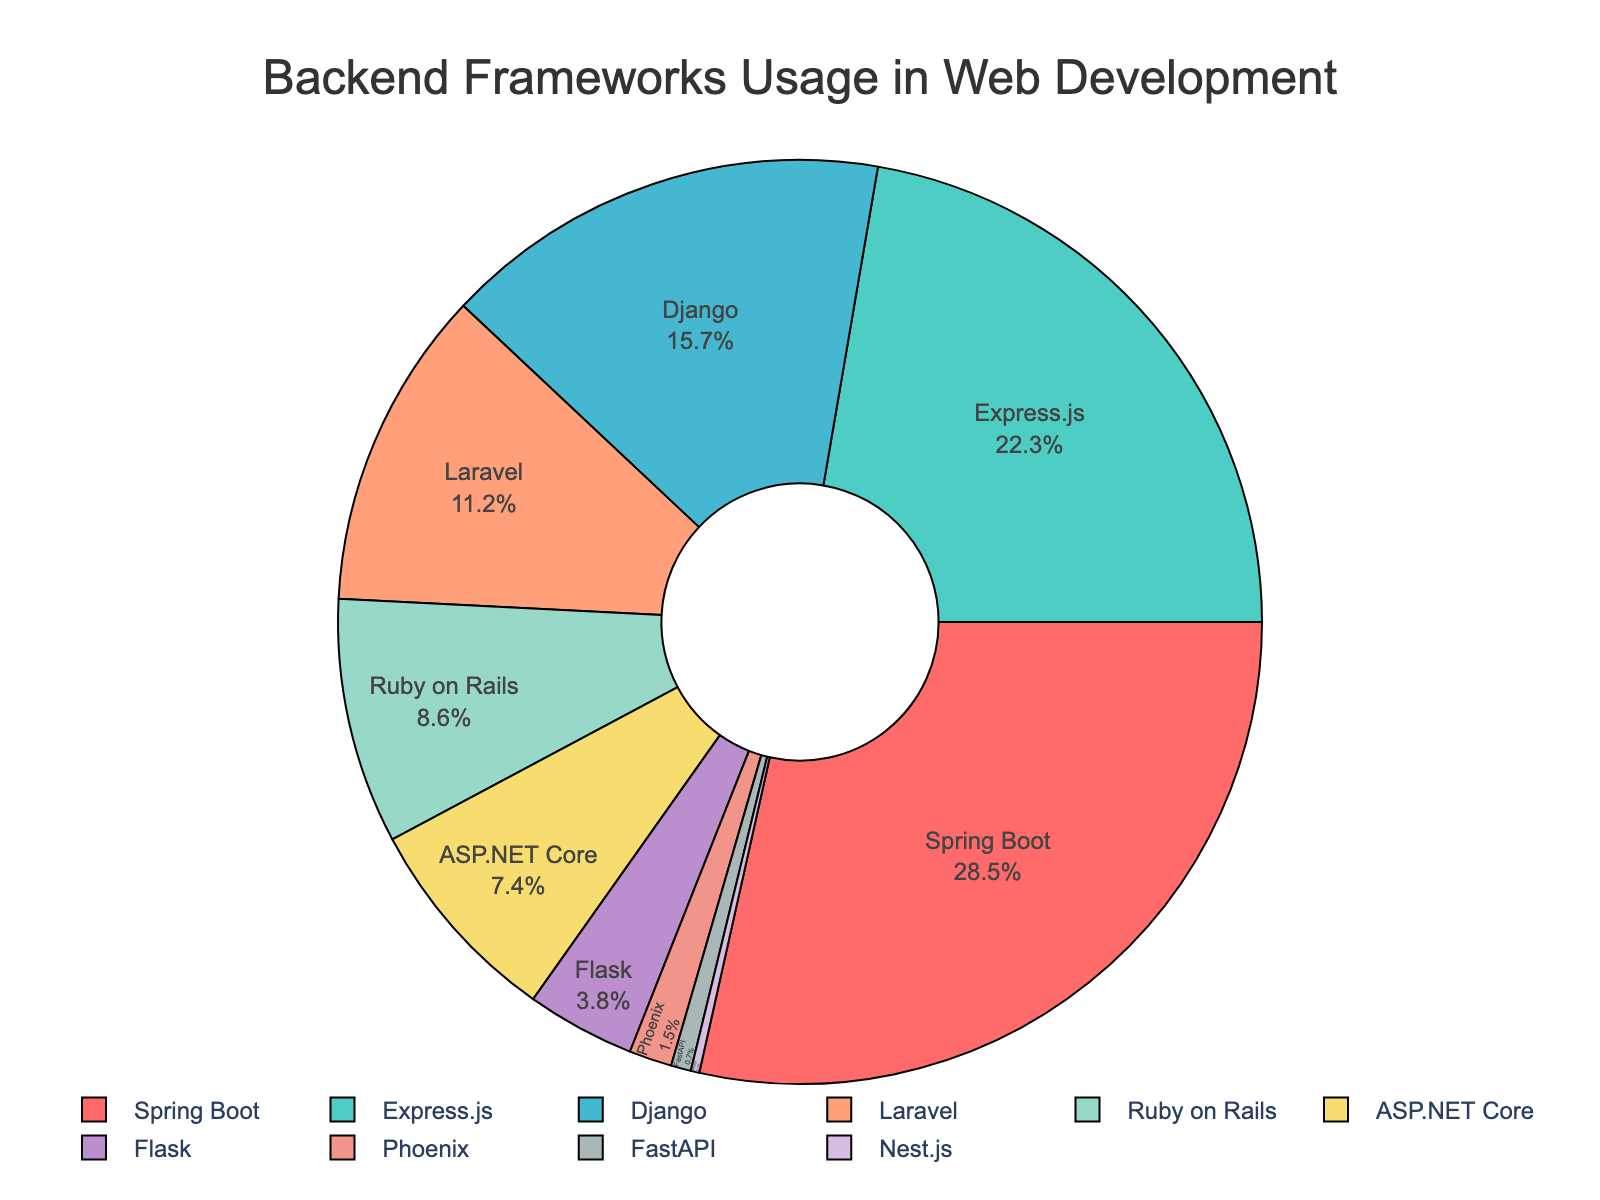What is the framework with the highest percentage usage? Looking at the figure, the segment corresponding to the highest usage percentage is for Spring Boot, which is clearly the largest slice.
Answer: Spring Boot How much more popular is Express.js compared to Django in terms of percentage? The figure shows that Express.js has a usage percentage of 22.3%, and Django has 15.7%. To find the difference, subtract Django's percentage from Express.js's percentage (22.3 - 15.7).
Answer: 6.6% Which frameworks have a usage percentage smaller than 5%? From the figure, we can see that Flask (3.8%), Phoenix (1.5%), FastAPI (0.7%), and Nest.js (0.3%) all have slices smaller than 5%.
Answer: Flask, Phoenix, FastAPI, Nest.js What is the combined percentage usage of Laravel and Ruby on Rails? By adding the percentage usage of Laravel (11.2%) and Ruby on Rails (8.6%) from the figure, we get 11.2 + 8.6.
Answer: 19.8% Between Django and ASP.NET Core, which one has the higher usage percentage and by how much? The figure indicates that Django has a usage percentage of 15.7%, while ASP.NET Core has 7.4%. To find the difference, subtract ASP.NET Core's percentage from Django's percentage (15.7 - 7.4).
Answer: Django by 8.3% What is the color of the slice representing Flask? Visually, the slice for Flask is marked with a distinctive color. From the predefined color scheme, Flask's slice is colored light blue.
Answer: Light blue What is the average usage percentage of the top three frameworks? The top three frameworks based on their percentages are Spring Boot (28.5%), Express.js (22.3%), and Django (15.7%). To find the average: (28.5 + 22.3 + 15.7) / 3.
Answer: 22.17% Which framework is represented by the smallest slice, and what is its percentage? The figure reveals the smallest slice belongs to Nest.js, which has a usage percentage of 0.3%.
Answer: Nest.js, 0.3% What percentage of usage is not occupied by the top two frameworks? The top two frameworks are Spring Boot (28.5%) and Express.js (22.3%). Adding these gives 50.8%. Subtracting this from 100% to find the rest: 100 - 50.8.
Answer: 49.2% If the usage percentages of Ruby on Rails and FastAPI were combined, would they surpass Flask's usage percentage? Ruby on Rails has 8.6% and FastAPI has 0.7%, adding them together gives 8.6 + 0.7 = 9.3%. Flask has 3.8%, so comparing 9.3% with 3.8%: Ruby on Rails + FastAPI indeed surpass Flask.
Answer: Yes 